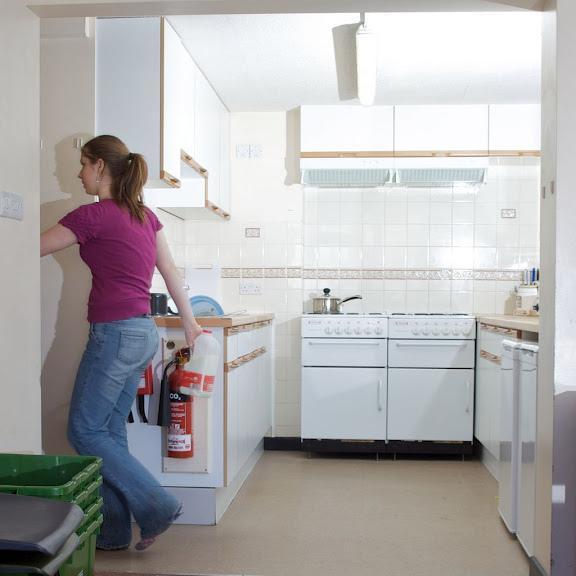How many cabinet doors are open?
Give a very brief answer. 0. 